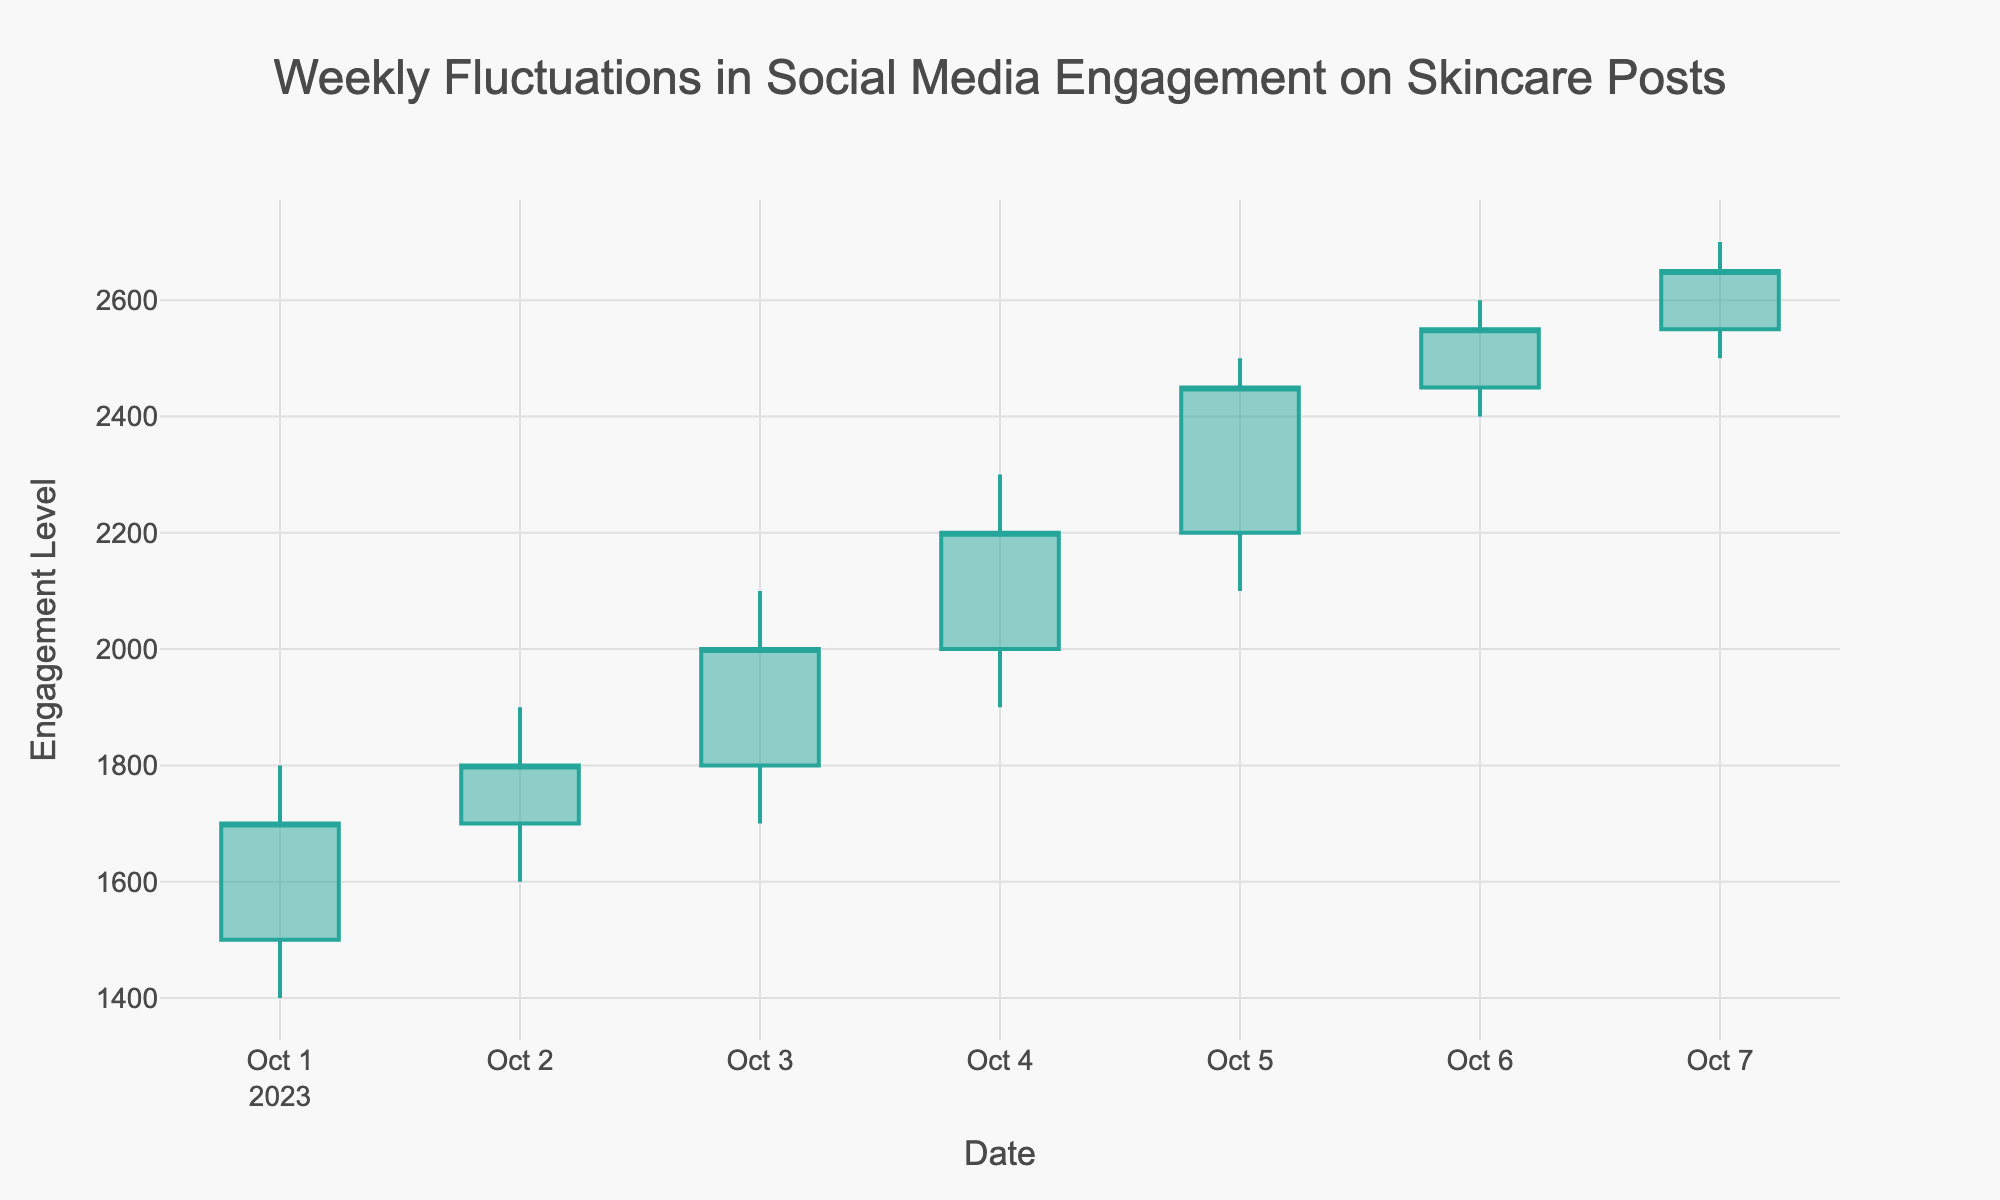What's the title of the candlestick plot? The title is generally placed at the top of the plot. In this case, it reads "Weekly Fluctuations in Social Media Engagement on Skincare Posts".
Answer: Weekly Fluctuations in Social Media Engagement on Skincare Posts What is the highest engagement level reached during the week? The highest engagement level is represented by the highest point on the vertical axis of the candlestick, which corresponds to the 'High' value of 2700 on October 7th.
Answer: 2700 On which date did the lowest engagement level occur? The lowest engagement level is denoted by the lowest 'Low' value in the candlestick plot, which is 1400 on October 1st.
Answer: October 1st What is the average closing engagement level for the week? To find the average, sum all the closing values (1700, 1800, 2000, 2200, 2450, 2550, 2650) and divide by the number of days (7). The calculation is (1700 + 1800 + 2000 + 2200 + 2450 + 2550 + 2650) / 7.
Answer: The average is 2192.86 Which day had the biggest difference between the high and low engagement levels? The difference between high and low is calculated for each day. The biggest difference is seen on October 5th with values (2500 - 2100) = 400.
Answer: October 5th Was there an overall increase or decrease in engagement from the start to the end of the week? Compare the opening engagement on October 1st (1500) with the closing engagement on October 7th (2650). There's an increase since 2650 is greater than 1500.
Answer: Increase How many days had a higher closing engagement level than the opening engagement level? Finding days where the closing value is higher than the opening value: 
- October 1st: 1700 > 1500
- October 3rd: 2000 > 1800
- October 4th: 2200 > 2000
- October 5th: 2450 > 2200
- October 6th: 2550 > 2450
- October 7th: 2650 > 2550. 
This occurs on 6 out of 7 days.
Answer: 6 days Which day showed the smallest range of engagement fluctuations? The range is calculated as the difference between high and low for each day. The smallest range is for October 6th with values (2600 - 2400) = 200.
Answer: October 6th What's the average high engagement level for the weekdays only (October 2nd - October 6th)? Sum the high values for weekdays (1900, 2100, 2300, 2500, 2600) and divide by the number of weekdays (5). The calculation is (1900 + 2100 + 2300 + 2500 + 2600) / 5.
Answer: The average is 2280 